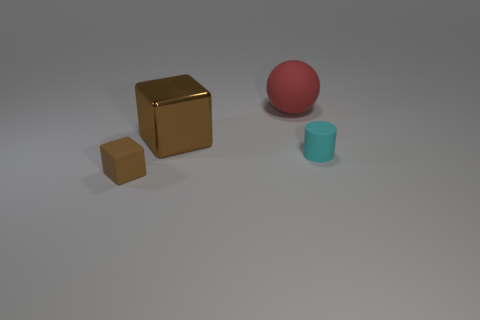Subtract 1 cylinders. How many cylinders are left? 0 Add 3 big blue spheres. How many objects exist? 7 Add 2 tiny cyan metal things. How many tiny cyan metal things exist? 2 Subtract 0 yellow cylinders. How many objects are left? 4 Subtract all blue balls. Subtract all cyan cylinders. How many balls are left? 1 Subtract all gray blocks. How many gray balls are left? 0 Subtract all tiny brown matte blocks. Subtract all large red matte spheres. How many objects are left? 2 Add 4 rubber balls. How many rubber balls are left? 5 